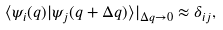<formula> <loc_0><loc_0><loc_500><loc_500>\langle \psi _ { i } ( q ) | \psi _ { j } ( q + \Delta q ) \rangle | _ { \Delta q \to 0 } \approx \delta _ { i j } ,</formula> 